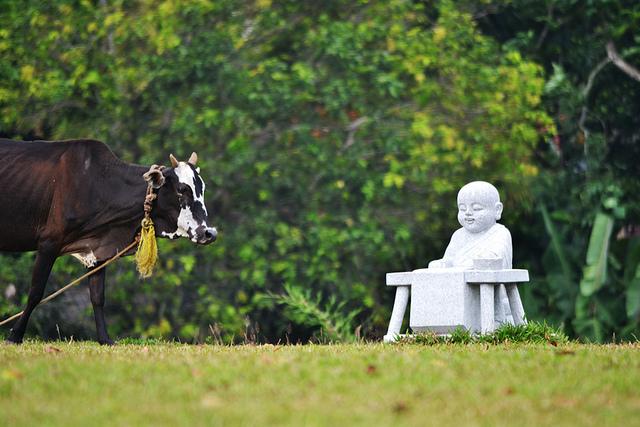Is the cow eating?
Answer briefly. No. What is on the cow?
Give a very brief answer. Rope. Is the grass green?
Be succinct. Yes. What country does this animal represent?
Answer briefly. India. Is the human real?
Answer briefly. No. What kind of animal is this?
Concise answer only. Cow. 